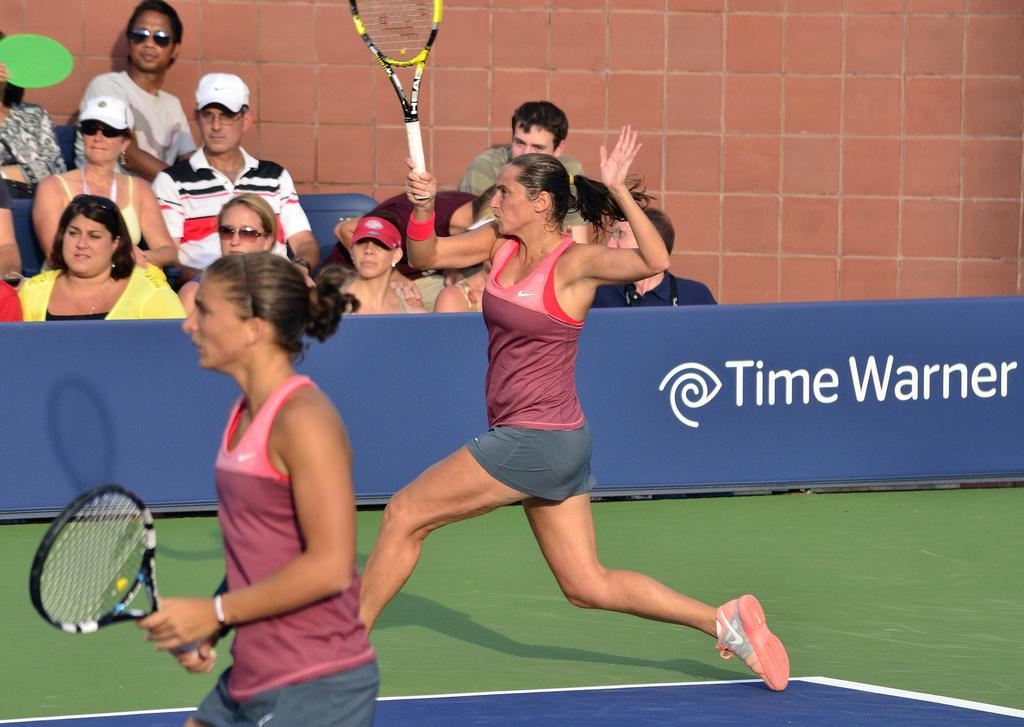Who are the main subjects in the image? Two women are standing in the middle of the image. What are the women holding in the image? The women are holding tennis rackets. What are the people behind the women doing? There are people sitting and watching behind the women. What can be seen in the top right side of the image? There is a wall in the top right side of the image. What type of honey is being served to the women in the image? There is no honey or any food or drink being served in the image; the women are holding tennis rackets. What is the relation between the two women in the image? The provided facts do not mention the relationship between the two women, so we cannot determine their relationship from the image. 